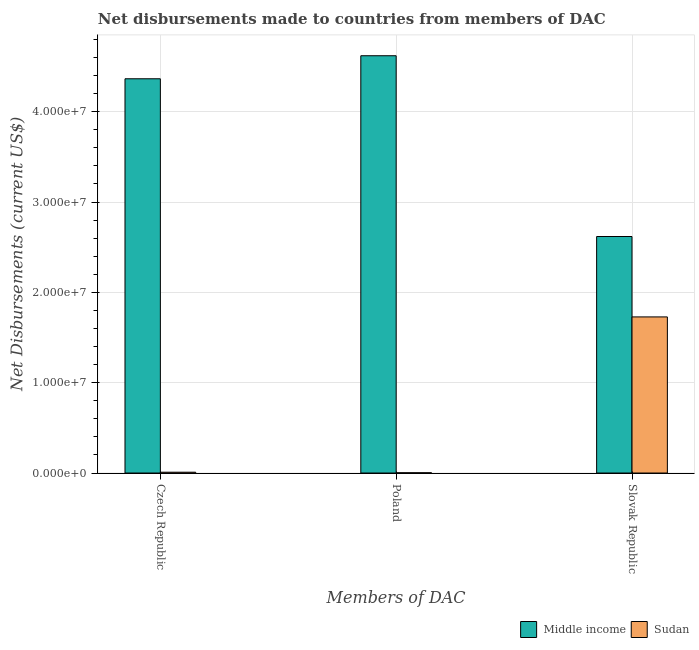Are the number of bars per tick equal to the number of legend labels?
Keep it short and to the point. Yes. Are the number of bars on each tick of the X-axis equal?
Your response must be concise. Yes. How many bars are there on the 3rd tick from the right?
Provide a short and direct response. 2. What is the label of the 3rd group of bars from the left?
Offer a very short reply. Slovak Republic. What is the net disbursements made by slovak republic in Middle income?
Give a very brief answer. 2.62e+07. Across all countries, what is the maximum net disbursements made by czech republic?
Ensure brevity in your answer.  4.36e+07. Across all countries, what is the minimum net disbursements made by czech republic?
Keep it short and to the point. 9.00e+04. In which country was the net disbursements made by czech republic maximum?
Ensure brevity in your answer.  Middle income. In which country was the net disbursements made by poland minimum?
Make the answer very short. Sudan. What is the total net disbursements made by czech republic in the graph?
Ensure brevity in your answer.  4.37e+07. What is the difference between the net disbursements made by slovak republic in Middle income and that in Sudan?
Provide a succinct answer. 8.90e+06. What is the difference between the net disbursements made by czech republic in Sudan and the net disbursements made by slovak republic in Middle income?
Your answer should be compact. -2.61e+07. What is the average net disbursements made by poland per country?
Your answer should be compact. 2.31e+07. What is the difference between the net disbursements made by poland and net disbursements made by czech republic in Middle income?
Make the answer very short. 2.55e+06. In how many countries, is the net disbursements made by slovak republic greater than 10000000 US$?
Your answer should be compact. 2. What is the ratio of the net disbursements made by poland in Sudan to that in Middle income?
Offer a very short reply. 0. Is the net disbursements made by czech republic in Middle income less than that in Sudan?
Provide a succinct answer. No. What is the difference between the highest and the second highest net disbursements made by czech republic?
Offer a very short reply. 4.36e+07. What is the difference between the highest and the lowest net disbursements made by slovak republic?
Your response must be concise. 8.90e+06. In how many countries, is the net disbursements made by slovak republic greater than the average net disbursements made by slovak republic taken over all countries?
Provide a short and direct response. 1. What does the 2nd bar from the left in Czech Republic represents?
Offer a terse response. Sudan. What does the 2nd bar from the right in Poland represents?
Your answer should be compact. Middle income. Is it the case that in every country, the sum of the net disbursements made by czech republic and net disbursements made by poland is greater than the net disbursements made by slovak republic?
Provide a short and direct response. No. Are all the bars in the graph horizontal?
Ensure brevity in your answer.  No. How many countries are there in the graph?
Ensure brevity in your answer.  2. What is the difference between two consecutive major ticks on the Y-axis?
Your answer should be very brief. 1.00e+07. Are the values on the major ticks of Y-axis written in scientific E-notation?
Keep it short and to the point. Yes. Does the graph contain any zero values?
Your response must be concise. No. Does the graph contain grids?
Your response must be concise. Yes. How are the legend labels stacked?
Give a very brief answer. Horizontal. What is the title of the graph?
Provide a succinct answer. Net disbursements made to countries from members of DAC. Does "Montenegro" appear as one of the legend labels in the graph?
Keep it short and to the point. No. What is the label or title of the X-axis?
Keep it short and to the point. Members of DAC. What is the label or title of the Y-axis?
Keep it short and to the point. Net Disbursements (current US$). What is the Net Disbursements (current US$) of Middle income in Czech Republic?
Offer a terse response. 4.36e+07. What is the Net Disbursements (current US$) of Middle income in Poland?
Offer a very short reply. 4.62e+07. What is the Net Disbursements (current US$) of Sudan in Poland?
Keep it short and to the point. 3.00e+04. What is the Net Disbursements (current US$) of Middle income in Slovak Republic?
Make the answer very short. 2.62e+07. What is the Net Disbursements (current US$) in Sudan in Slovak Republic?
Provide a short and direct response. 1.73e+07. Across all Members of DAC, what is the maximum Net Disbursements (current US$) of Middle income?
Offer a terse response. 4.62e+07. Across all Members of DAC, what is the maximum Net Disbursements (current US$) in Sudan?
Give a very brief answer. 1.73e+07. Across all Members of DAC, what is the minimum Net Disbursements (current US$) in Middle income?
Offer a terse response. 2.62e+07. What is the total Net Disbursements (current US$) in Middle income in the graph?
Your answer should be compact. 1.16e+08. What is the total Net Disbursements (current US$) of Sudan in the graph?
Your response must be concise. 1.74e+07. What is the difference between the Net Disbursements (current US$) in Middle income in Czech Republic and that in Poland?
Provide a succinct answer. -2.55e+06. What is the difference between the Net Disbursements (current US$) in Middle income in Czech Republic and that in Slovak Republic?
Offer a very short reply. 1.75e+07. What is the difference between the Net Disbursements (current US$) of Sudan in Czech Republic and that in Slovak Republic?
Offer a very short reply. -1.72e+07. What is the difference between the Net Disbursements (current US$) in Middle income in Poland and that in Slovak Republic?
Your response must be concise. 2.00e+07. What is the difference between the Net Disbursements (current US$) of Sudan in Poland and that in Slovak Republic?
Your response must be concise. -1.72e+07. What is the difference between the Net Disbursements (current US$) in Middle income in Czech Republic and the Net Disbursements (current US$) in Sudan in Poland?
Ensure brevity in your answer.  4.36e+07. What is the difference between the Net Disbursements (current US$) in Middle income in Czech Republic and the Net Disbursements (current US$) in Sudan in Slovak Republic?
Your response must be concise. 2.64e+07. What is the difference between the Net Disbursements (current US$) in Middle income in Poland and the Net Disbursements (current US$) in Sudan in Slovak Republic?
Provide a short and direct response. 2.89e+07. What is the average Net Disbursements (current US$) of Middle income per Members of DAC?
Give a very brief answer. 3.87e+07. What is the average Net Disbursements (current US$) of Sudan per Members of DAC?
Offer a terse response. 5.80e+06. What is the difference between the Net Disbursements (current US$) in Middle income and Net Disbursements (current US$) in Sudan in Czech Republic?
Your answer should be compact. 4.36e+07. What is the difference between the Net Disbursements (current US$) in Middle income and Net Disbursements (current US$) in Sudan in Poland?
Your answer should be compact. 4.62e+07. What is the difference between the Net Disbursements (current US$) of Middle income and Net Disbursements (current US$) of Sudan in Slovak Republic?
Provide a short and direct response. 8.90e+06. What is the ratio of the Net Disbursements (current US$) in Middle income in Czech Republic to that in Poland?
Offer a terse response. 0.94. What is the ratio of the Net Disbursements (current US$) in Middle income in Czech Republic to that in Slovak Republic?
Keep it short and to the point. 1.67. What is the ratio of the Net Disbursements (current US$) in Sudan in Czech Republic to that in Slovak Republic?
Keep it short and to the point. 0.01. What is the ratio of the Net Disbursements (current US$) of Middle income in Poland to that in Slovak Republic?
Make the answer very short. 1.76. What is the ratio of the Net Disbursements (current US$) of Sudan in Poland to that in Slovak Republic?
Your answer should be very brief. 0. What is the difference between the highest and the second highest Net Disbursements (current US$) in Middle income?
Your answer should be very brief. 2.55e+06. What is the difference between the highest and the second highest Net Disbursements (current US$) of Sudan?
Provide a succinct answer. 1.72e+07. What is the difference between the highest and the lowest Net Disbursements (current US$) in Middle income?
Provide a short and direct response. 2.00e+07. What is the difference between the highest and the lowest Net Disbursements (current US$) of Sudan?
Your response must be concise. 1.72e+07. 